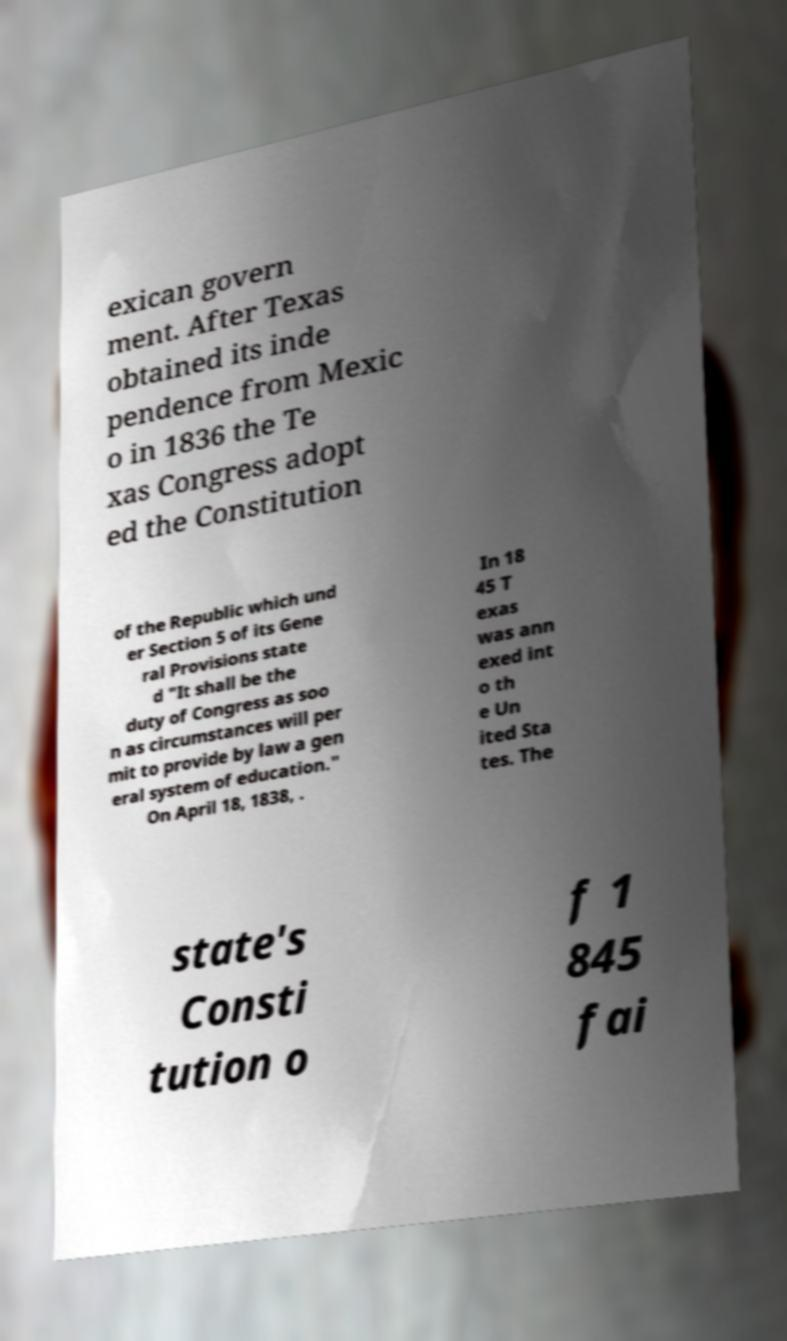I need the written content from this picture converted into text. Can you do that? exican govern ment. After Texas obtained its inde pendence from Mexic o in 1836 the Te xas Congress adopt ed the Constitution of the Republic which und er Section 5 of its Gene ral Provisions state d "It shall be the duty of Congress as soo n as circumstances will per mit to provide by law a gen eral system of education." On April 18, 1838, . In 18 45 T exas was ann exed int o th e Un ited Sta tes. The state's Consti tution o f 1 845 fai 